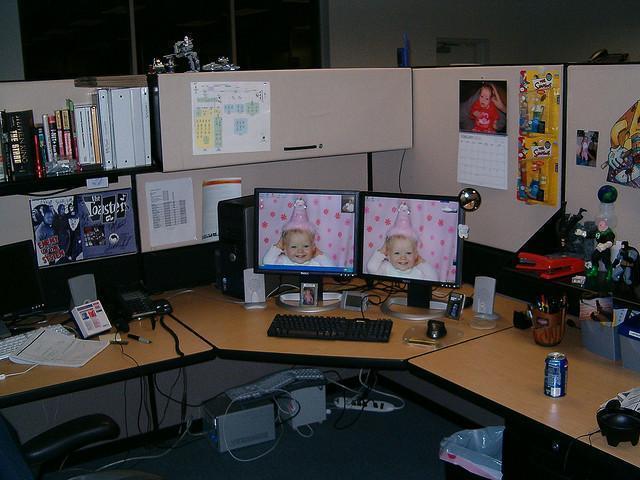Where is this desk setup?
Indicate the correct choice and explain in the format: 'Answer: answer
Rationale: rationale.'
Options: In hallway, on train, at work, in library. Answer: at work.
Rationale: The desk setup is in the office. 